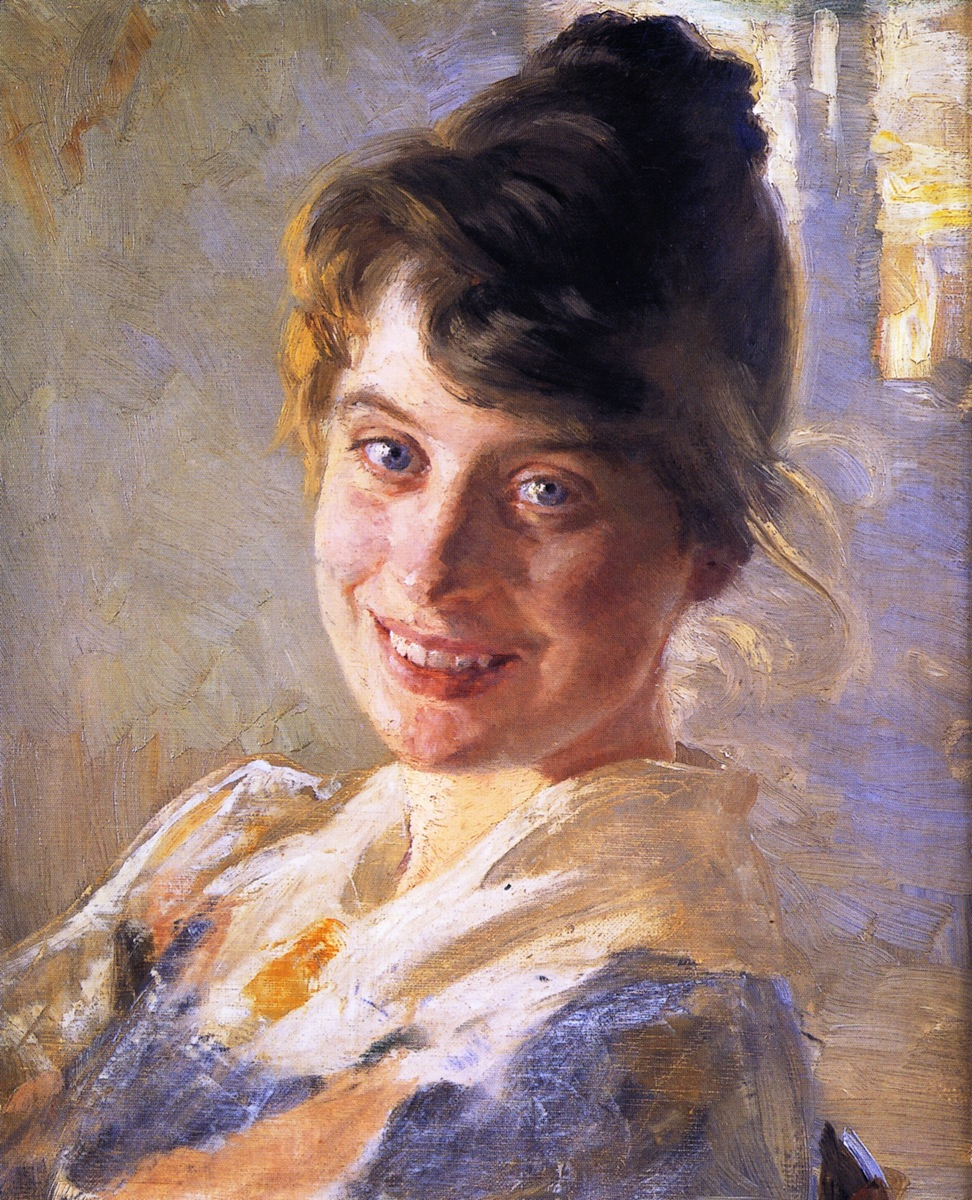What is the mood conveyed in this painting and how does the artist achieve it? The mood conveyed in this painting is one of warmth, joy, and light-heartedness. The artist achieves this through the use of a bright color palette, especially the light blues and yellows in the background, which create a soft, airy atmosphere. Additionally, the woman's warm and genuine smile adds a cheerful and lively tone to the piece. The loose brushstrokes typical of the impressionist style also contribute by adding a sense of movement and lightness, avoiding the rigidity that might otherwise detract from the overall joyful mood. Can you provide some historical context about the impressionist style and its characteristics? The impressionist style emerged in France during the late 19th century and is characterized by its emphasis on light and color over precise detail. This movement sought to capture the momentary and transient effects of sunlight by painting en plein air, or outdoors. Artists used quick, spontaneous brushstrokes to convey their impressions of a scene rather than a detailed, realistic portrayal. Impressionism marked a shift away from the more structured and formal techniques of academic painting, focusing instead on everyday subject matter, and often depicting landscapes, urban scenes, and social activities in natural light. Notable impressionist artists include Claude Monet, Pierre-Auguste Renoir, and Édouard Manet, among others. 